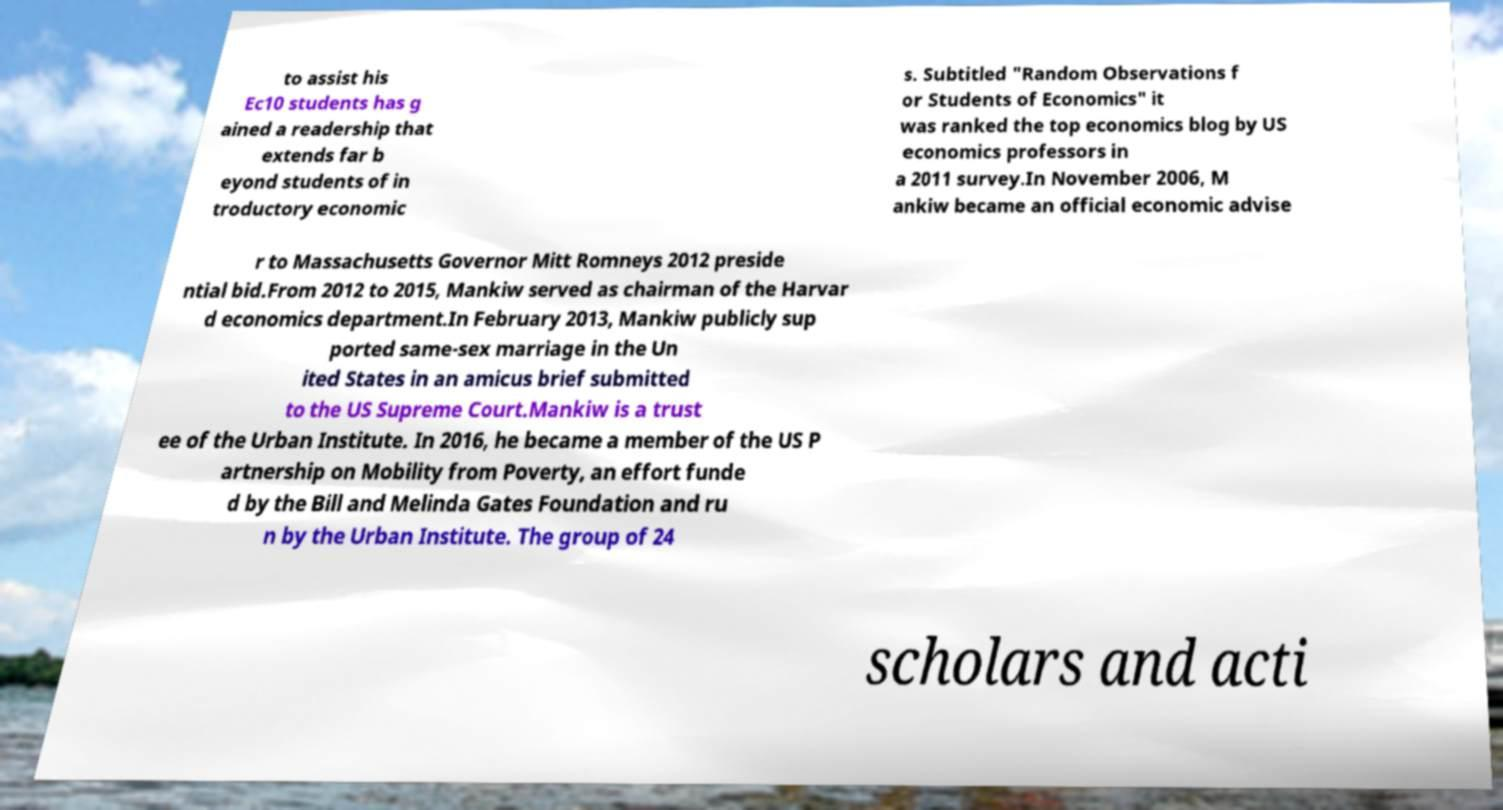Could you assist in decoding the text presented in this image and type it out clearly? to assist his Ec10 students has g ained a readership that extends far b eyond students of in troductory economic s. Subtitled "Random Observations f or Students of Economics" it was ranked the top economics blog by US economics professors in a 2011 survey.In November 2006, M ankiw became an official economic advise r to Massachusetts Governor Mitt Romneys 2012 preside ntial bid.From 2012 to 2015, Mankiw served as chairman of the Harvar d economics department.In February 2013, Mankiw publicly sup ported same-sex marriage in the Un ited States in an amicus brief submitted to the US Supreme Court.Mankiw is a trust ee of the Urban Institute. In 2016, he became a member of the US P artnership on Mobility from Poverty, an effort funde d by the Bill and Melinda Gates Foundation and ru n by the Urban Institute. The group of 24 scholars and acti 